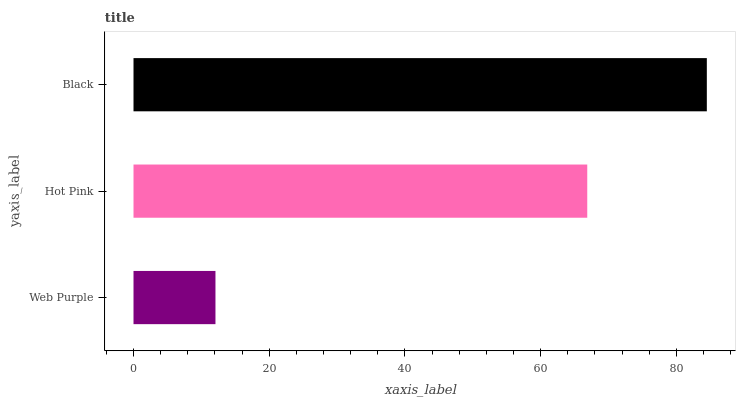Is Web Purple the minimum?
Answer yes or no. Yes. Is Black the maximum?
Answer yes or no. Yes. Is Hot Pink the minimum?
Answer yes or no. No. Is Hot Pink the maximum?
Answer yes or no. No. Is Hot Pink greater than Web Purple?
Answer yes or no. Yes. Is Web Purple less than Hot Pink?
Answer yes or no. Yes. Is Web Purple greater than Hot Pink?
Answer yes or no. No. Is Hot Pink less than Web Purple?
Answer yes or no. No. Is Hot Pink the high median?
Answer yes or no. Yes. Is Hot Pink the low median?
Answer yes or no. Yes. Is Web Purple the high median?
Answer yes or no. No. Is Black the low median?
Answer yes or no. No. 